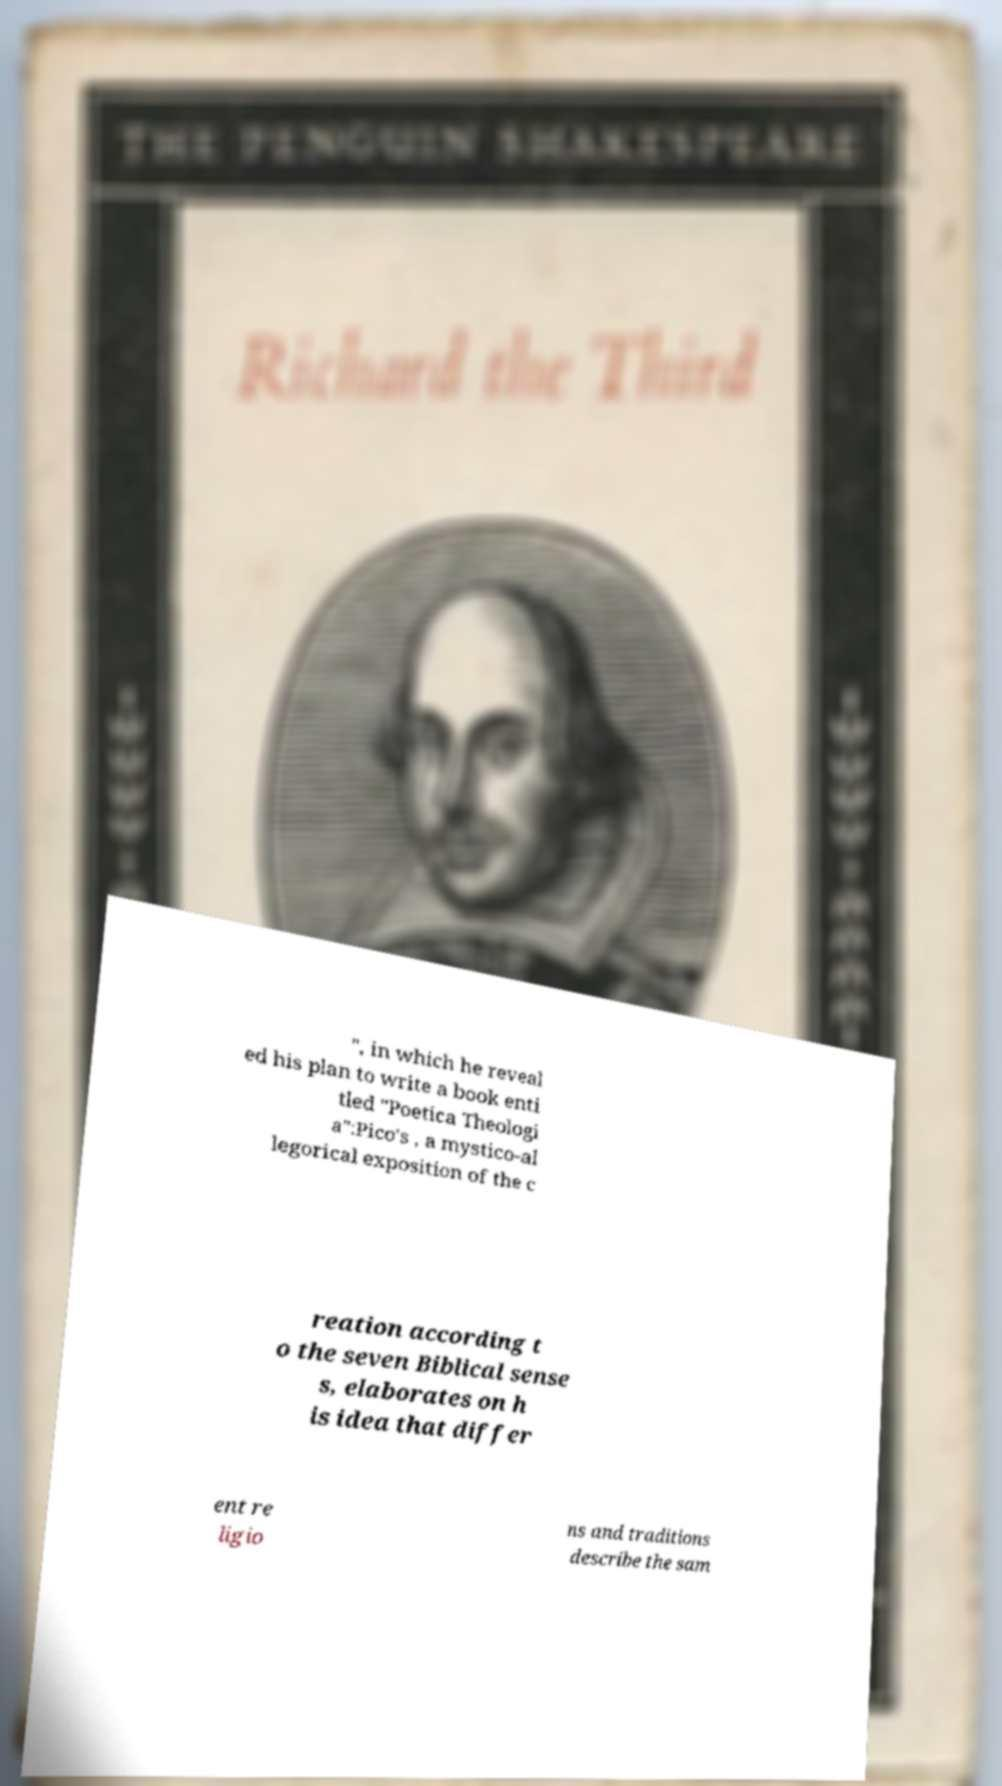There's text embedded in this image that I need extracted. Can you transcribe it verbatim? ", in which he reveal ed his plan to write a book enti tled "Poetica Theologi a":Pico's , a mystico-al legorical exposition of the c reation according t o the seven Biblical sense s, elaborates on h is idea that differ ent re ligio ns and traditions describe the sam 